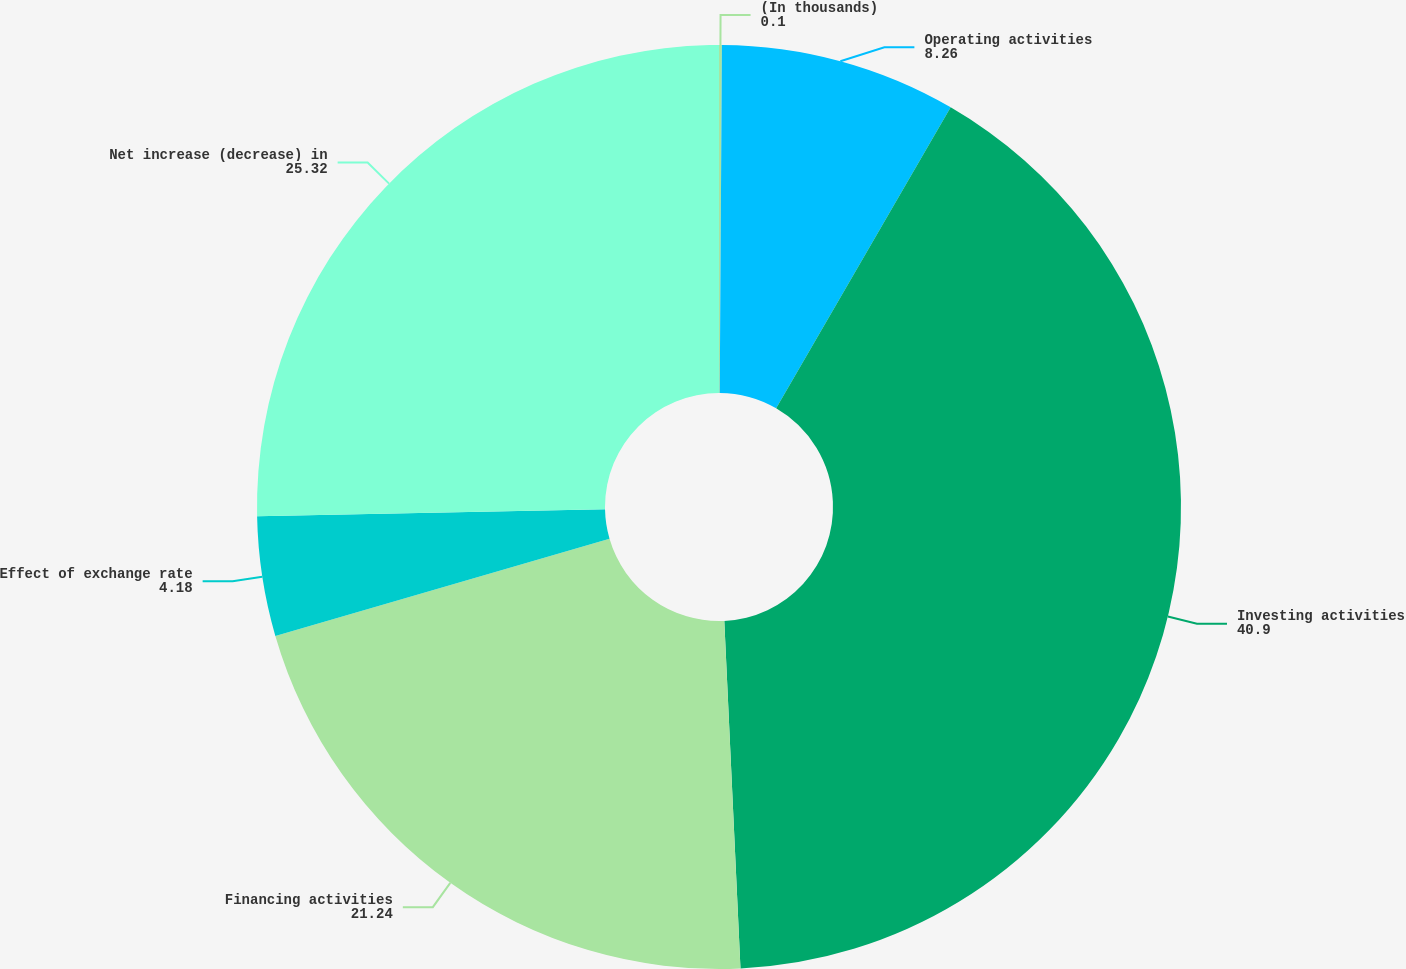<chart> <loc_0><loc_0><loc_500><loc_500><pie_chart><fcel>(In thousands)<fcel>Operating activities<fcel>Investing activities<fcel>Financing activities<fcel>Effect of exchange rate<fcel>Net increase (decrease) in<nl><fcel>0.1%<fcel>8.26%<fcel>40.9%<fcel>21.24%<fcel>4.18%<fcel>25.32%<nl></chart> 